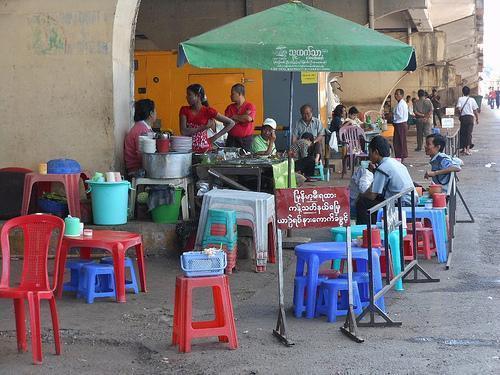How many volunteers are wearing red shirts?
Give a very brief answer. 3. 